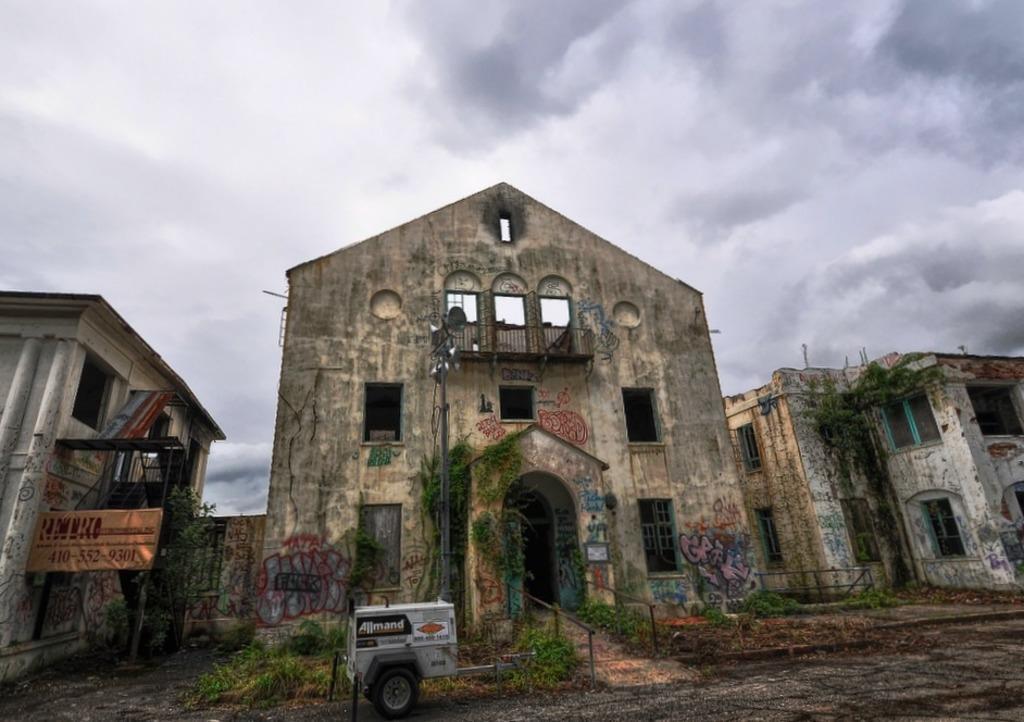Describe this image in one or two sentences. In this picture we can see a vehicle on the ground, name board, plants, pole, buildings with windows and in the background we can see the sky with clouds. 